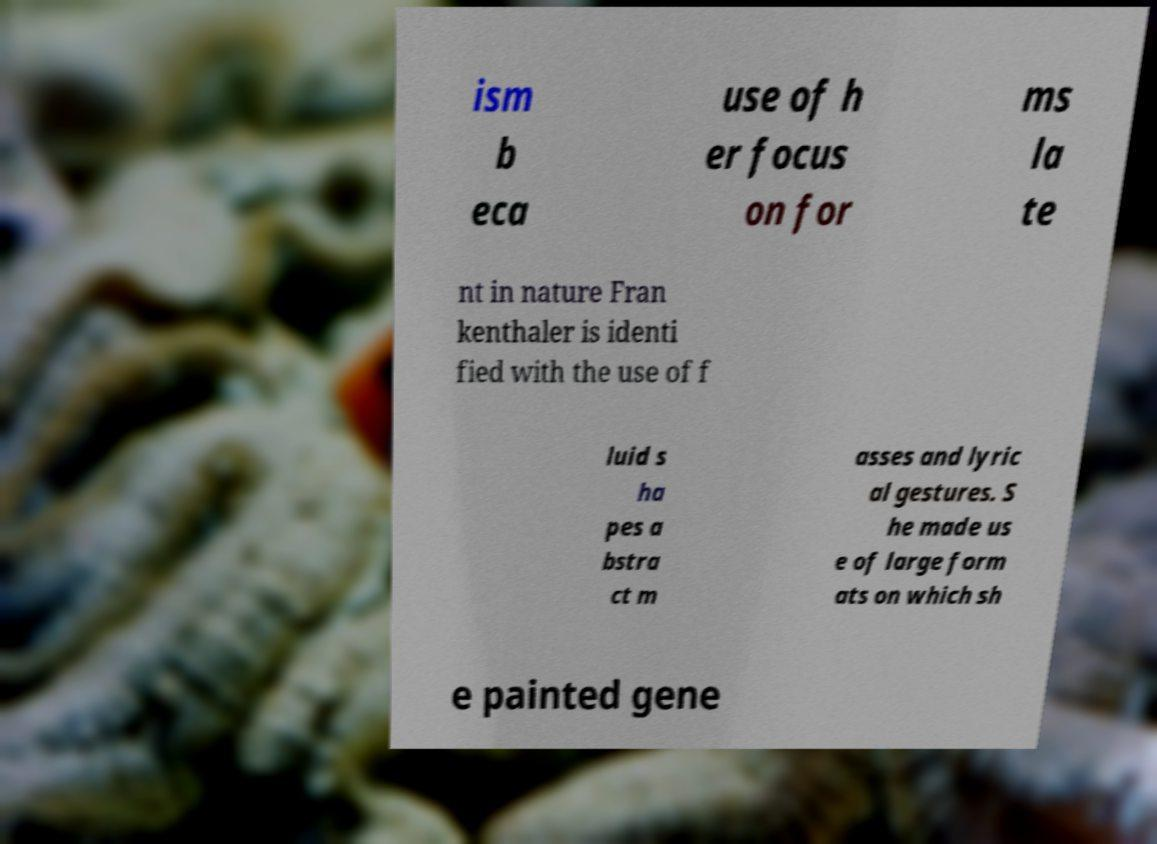There's text embedded in this image that I need extracted. Can you transcribe it verbatim? ism b eca use of h er focus on for ms la te nt in nature Fran kenthaler is identi fied with the use of f luid s ha pes a bstra ct m asses and lyric al gestures. S he made us e of large form ats on which sh e painted gene 